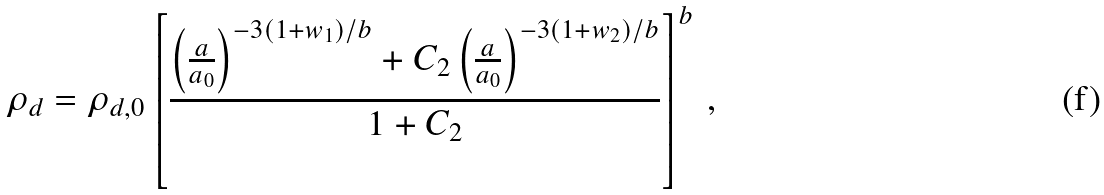Convert formula to latex. <formula><loc_0><loc_0><loc_500><loc_500>\rho _ { d } = \rho _ { d , 0 } \left [ \frac { \left ( \frac { a } { a _ { 0 } } \right ) ^ { - 3 ( 1 + w _ { 1 } ) / b } + C _ { 2 } \left ( \frac { a } { a _ { 0 } } \right ) ^ { - 3 ( 1 + w _ { 2 } ) / b } } { 1 + C _ { 2 } } \right ] ^ { b } \, ,</formula> 